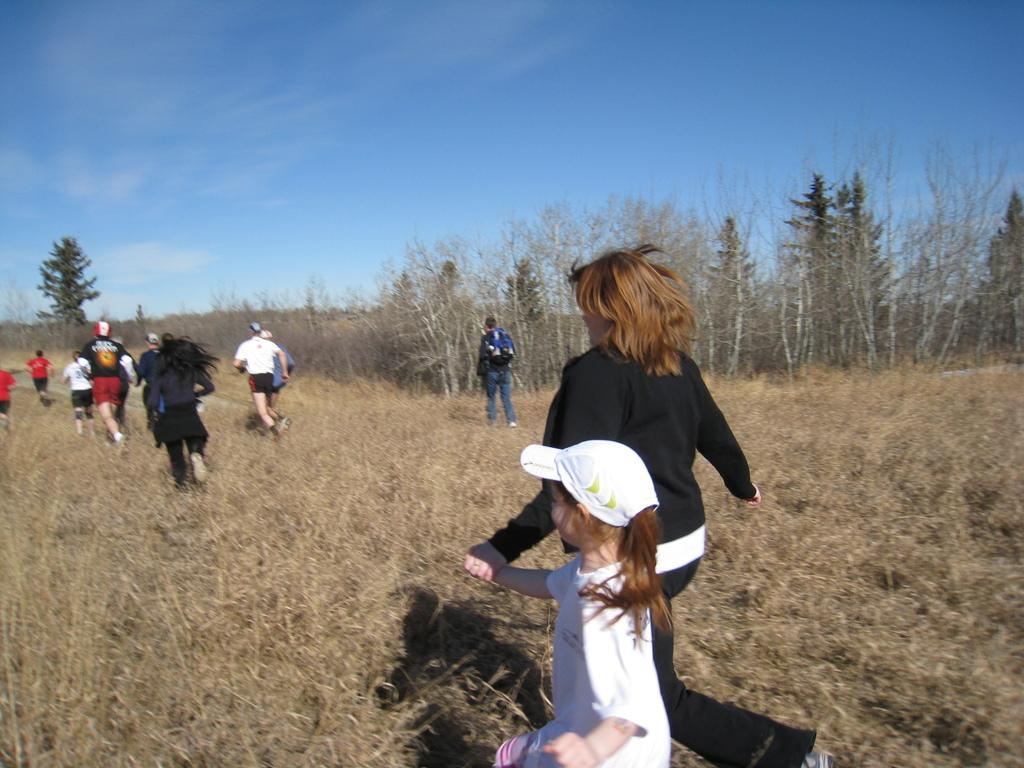How many people are in the image? There are many people in the image. What are the people doing in the image? The people are running. Can you describe the clothing of some people in the image? Some people are wearing caps. What is the ground made of in the image? There is grass on the ground. What can be seen in the background of the image? There are trees and the sky in the background. What is the condition of the sky in the image? Clouds are present in the sky. Can you tell me what hobbies the tiger in the image enjoys? There is no tiger present in the image, so we cannot determine its hobbies. What type of slip is visible on the people's feet? The provided facts do not mention any type of slip on the people's feet. 